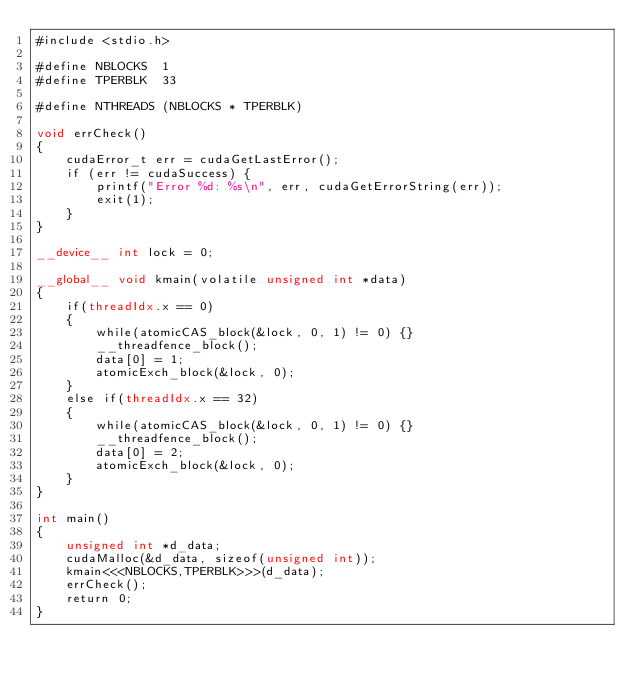<code> <loc_0><loc_0><loc_500><loc_500><_Cuda_>#include <stdio.h>

#define NBLOCKS  1
#define TPERBLK  33

#define NTHREADS (NBLOCKS * TPERBLK)

void errCheck()
{
    cudaError_t err = cudaGetLastError();
    if (err != cudaSuccess) {
        printf("Error %d: %s\n", err, cudaGetErrorString(err));
        exit(1);
    }
}

__device__ int lock = 0;

__global__ void kmain(volatile unsigned int *data) 
{
    if(threadIdx.x == 0)
    {
        while(atomicCAS_block(&lock, 0, 1) != 0) {}
        __threadfence_block();
        data[0] = 1;
        atomicExch_block(&lock, 0);
    }
    else if(threadIdx.x == 32)
    {
        while(atomicCAS_block(&lock, 0, 1) != 0) {}
        __threadfence_block();
        data[0] = 2;
        atomicExch_block(&lock, 0);
    }
}

int main() 
{
    unsigned int *d_data;
    cudaMalloc(&d_data, sizeof(unsigned int));
    kmain<<<NBLOCKS,TPERBLK>>>(d_data);
    errCheck();
    return 0;
}

</code> 